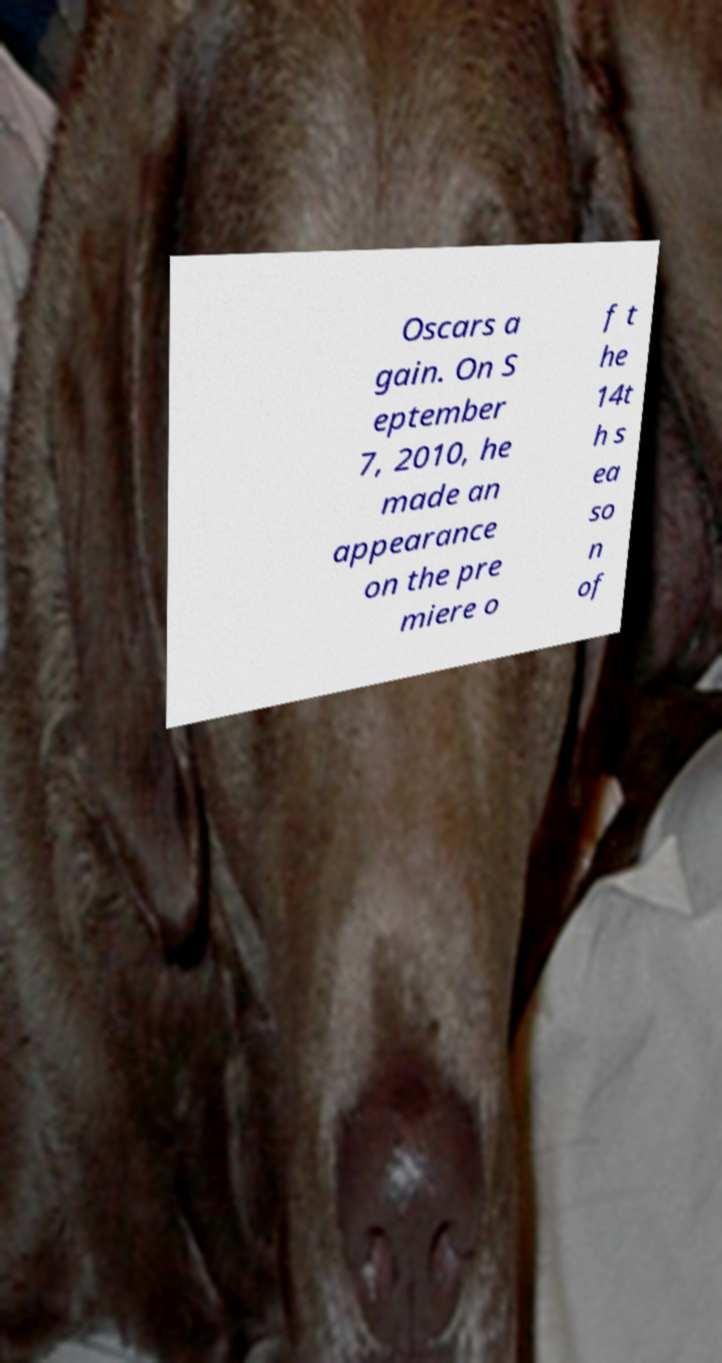Can you accurately transcribe the text from the provided image for me? Oscars a gain. On S eptember 7, 2010, he made an appearance on the pre miere o f t he 14t h s ea so n of 